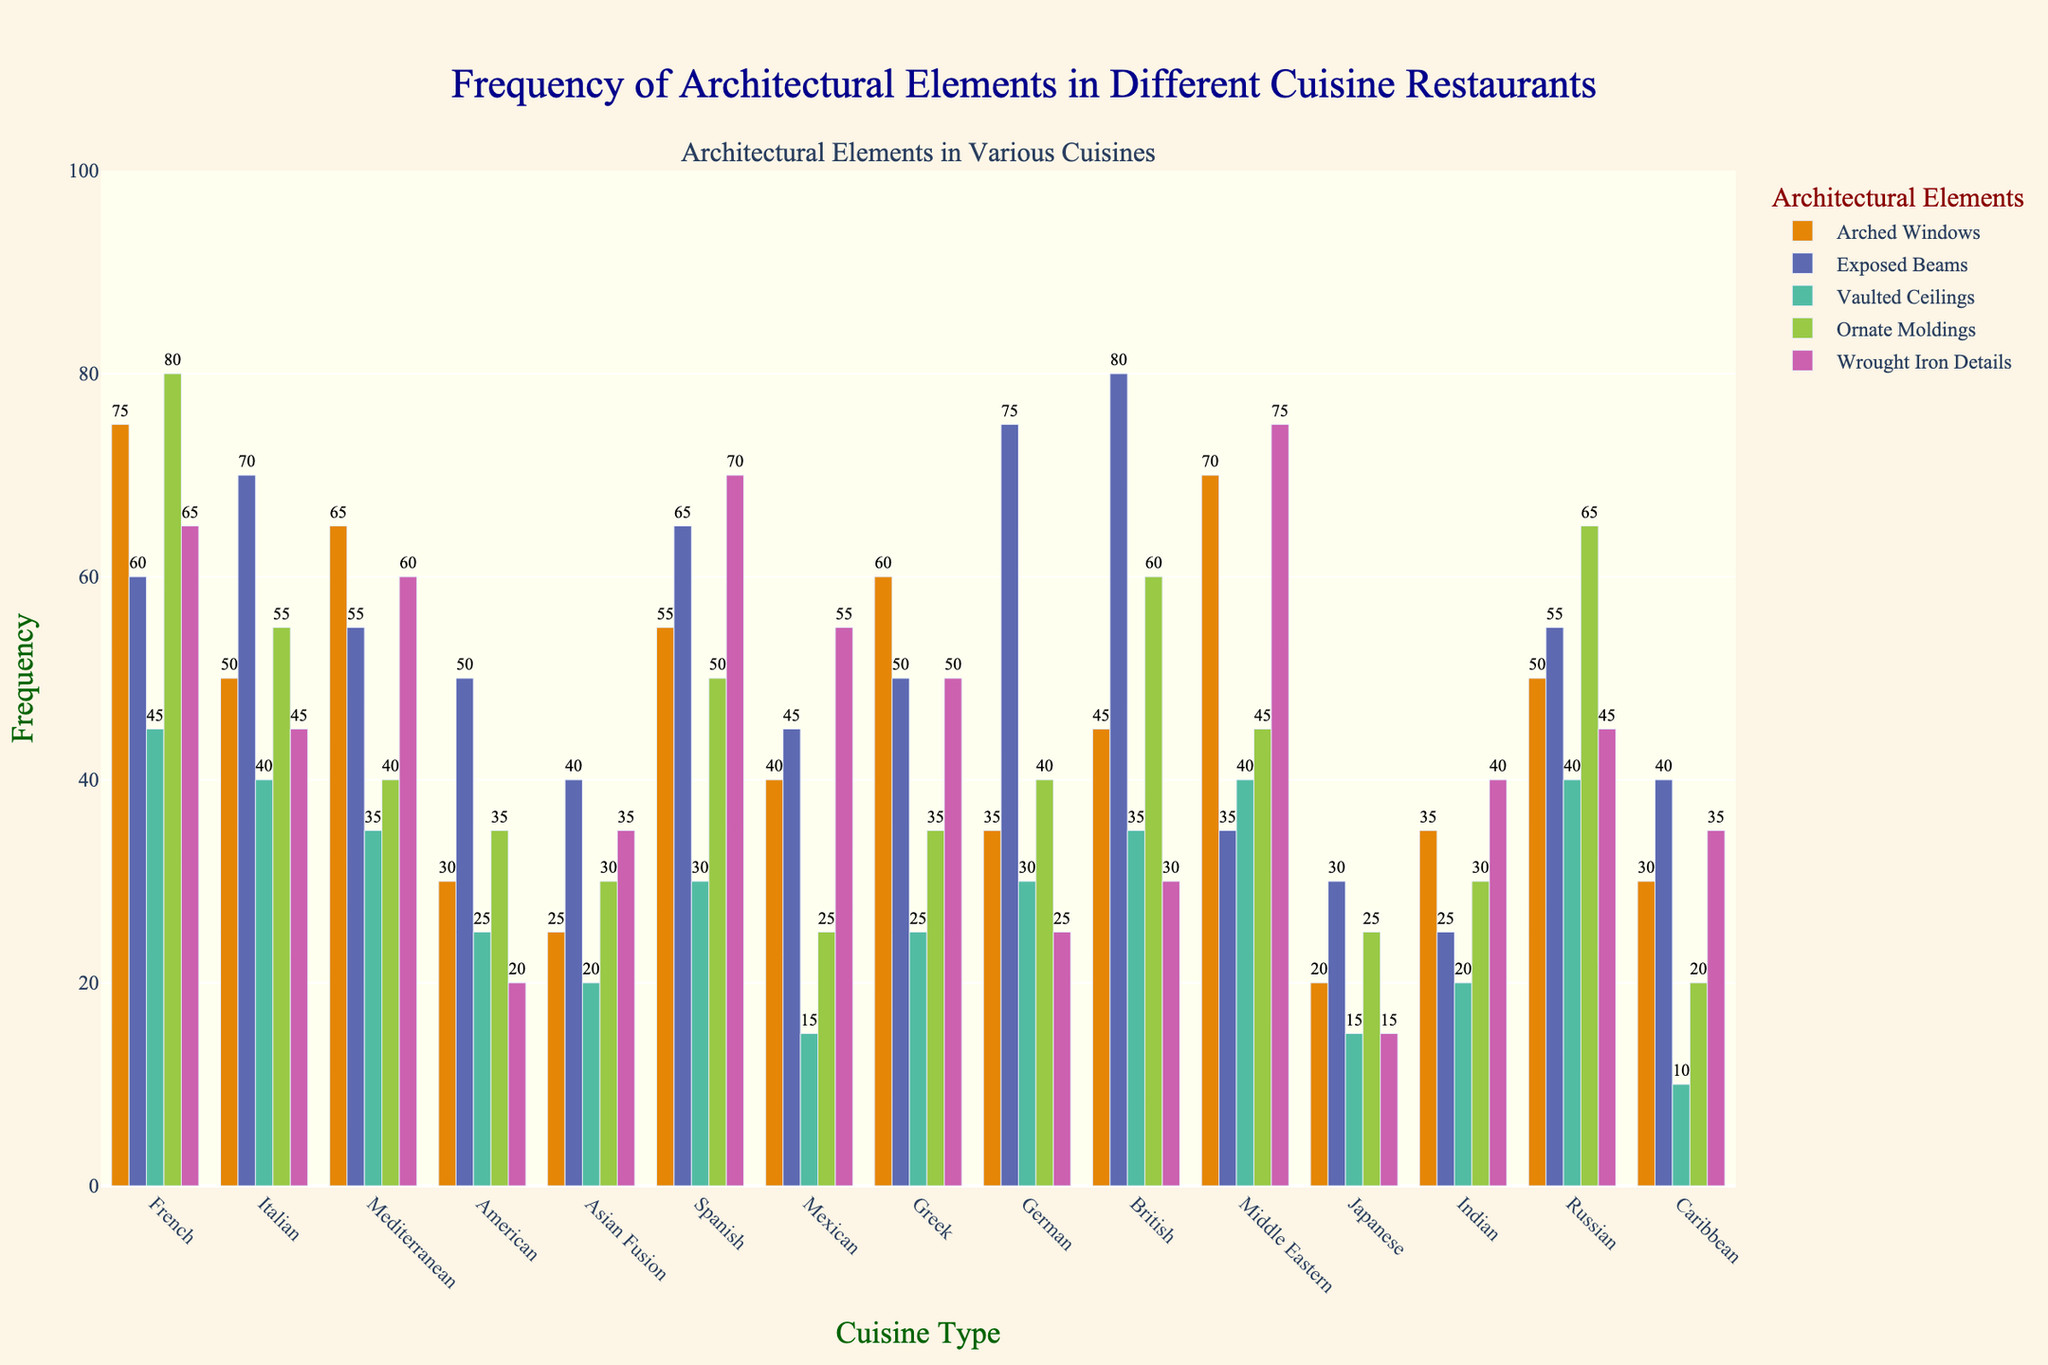Which cuisine type features the highest frequency of ornate moldings? French cuisine shows the highest frequency of ornate moldings, as the bar representing this element is the tallest in comparison to all other cuisines.
Answer: French What is the combined frequency of wrought iron details in French and Spanish cuisines? The frequency of wrought iron details in French cuisine is 65, and in Spanish cuisine, it is 70. Adding these two values gives 65 + 70 = 135.
Answer: 135 Which architectural element is most frequently observed in British cuisine? The tallest bar within the British cuisine category corresponds to Exposed Beams with a frequency of 80.
Answer: Exposed Beams How does the frequency of arched windows in Mediterranean cuisine compare to that in Greek cuisine? The frequency of arched windows in Mediterranean cuisine is 65, while in Greek cuisine it is 60. 65 is slightly higher than 60.
Answer: Mediterranean is higher What is the average frequency of vaulted ceilings across all cuisines? Sum up the frequencies of vaulted ceilings for all cuisines (45 + 40 + 35 + 25 + 20 + 30 + 15 + 25 + 30 + 35 + 40 + 15 + 20 + 40 + 10 = 415). There are 15 cuisine types, so the average frequency is 415 / 15 ≈ 27.67.
Answer: 27.67 Which cuisine has the least frequency of arched windows and what is its value? Looking at the bar heights for arched windows, Japanese cuisine has the smallest bar, representing a frequency of 20.
Answer: Japanese, 20 Is the frequency of exposed beams higher in French or American cuisine? Comparing the heights of the bars for exposed beams in French and American cuisines, French is 60 and American is 50. Thus, French is higher.
Answer: French What is the sum of frequencies for all architectural elements in German cuisine? Add up all the frequencies for German cuisine (35 + 75 + 30 + 40 + 25). The total frequency is 35 + 75 + 30 + 40 + 25 = 205.
Answer: 205 Identify which cuisine type has the highest variance in the frequency of architectural elements? To determine the highest variance, observe the spread between the highest and lowest values for each cuisine. British cuisine has the largest spread with exposed beams (80) and vaulted ceilings (35), and the difference here is 80 - 35 = 45.
Answer: British 